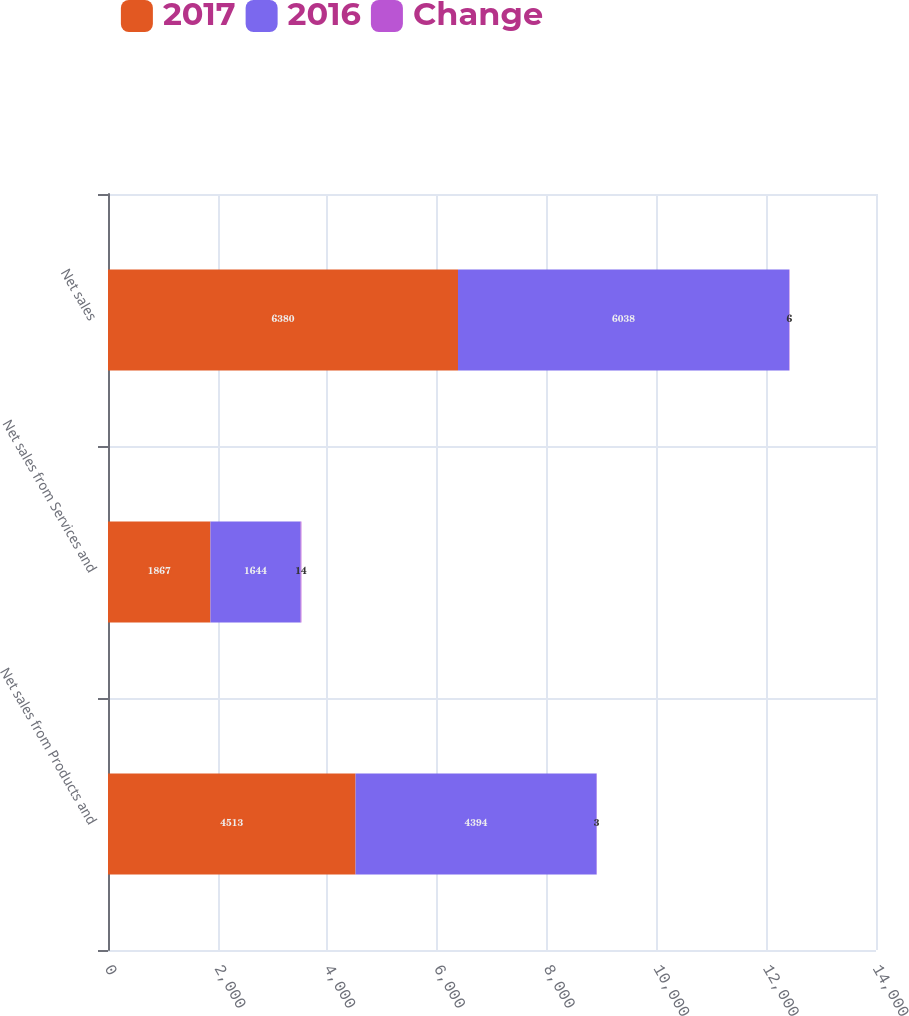Convert chart. <chart><loc_0><loc_0><loc_500><loc_500><stacked_bar_chart><ecel><fcel>Net sales from Products and<fcel>Net sales from Services and<fcel>Net sales<nl><fcel>2017<fcel>4513<fcel>1867<fcel>6380<nl><fcel>2016<fcel>4394<fcel>1644<fcel>6038<nl><fcel>Change<fcel>3<fcel>14<fcel>6<nl></chart> 